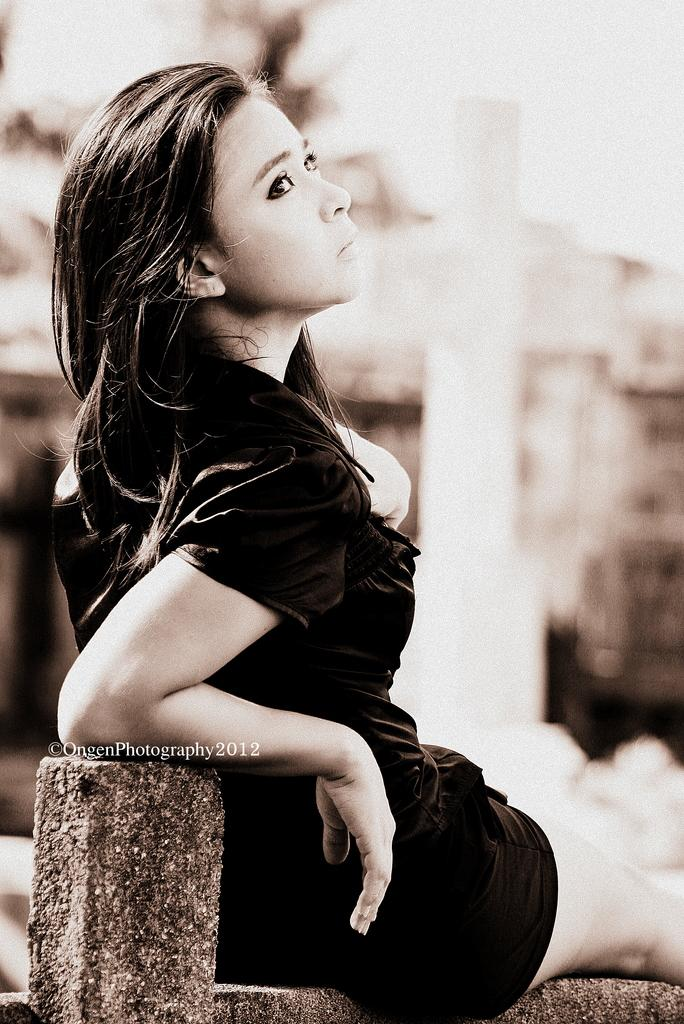Who is the main subject in the image? There is a girl in the image. What is the girl wearing? The girl is wearing a black dress. What is the girl doing in the image? The girl is sitting on a wall. Can you describe the background of the image? The background of the image is blurred. What type of operation is being performed on the box in the image? There is no box or operation present in the image; it features a girl sitting on a wall. What is the current status of the girl in the image? The image does not provide information about the girl's current status or any ongoing events. 